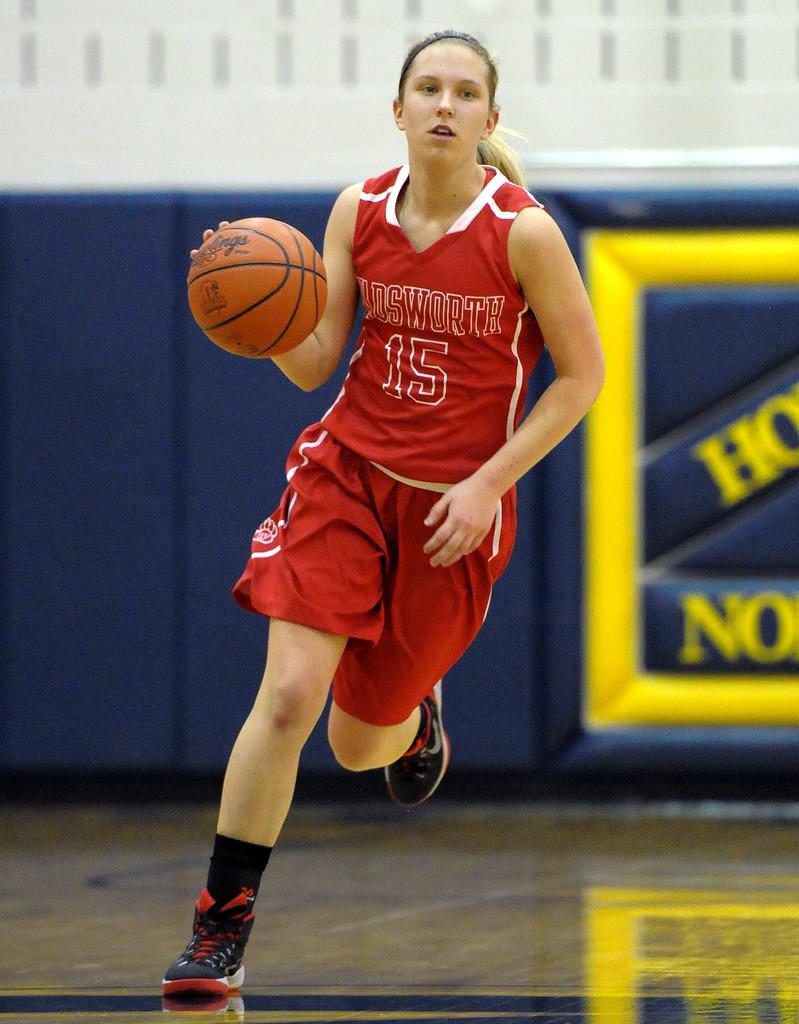<image>
Offer a succinct explanation of the picture presented. A girl wearing a red uniform with the number 15 on it runs down the court with the ball 